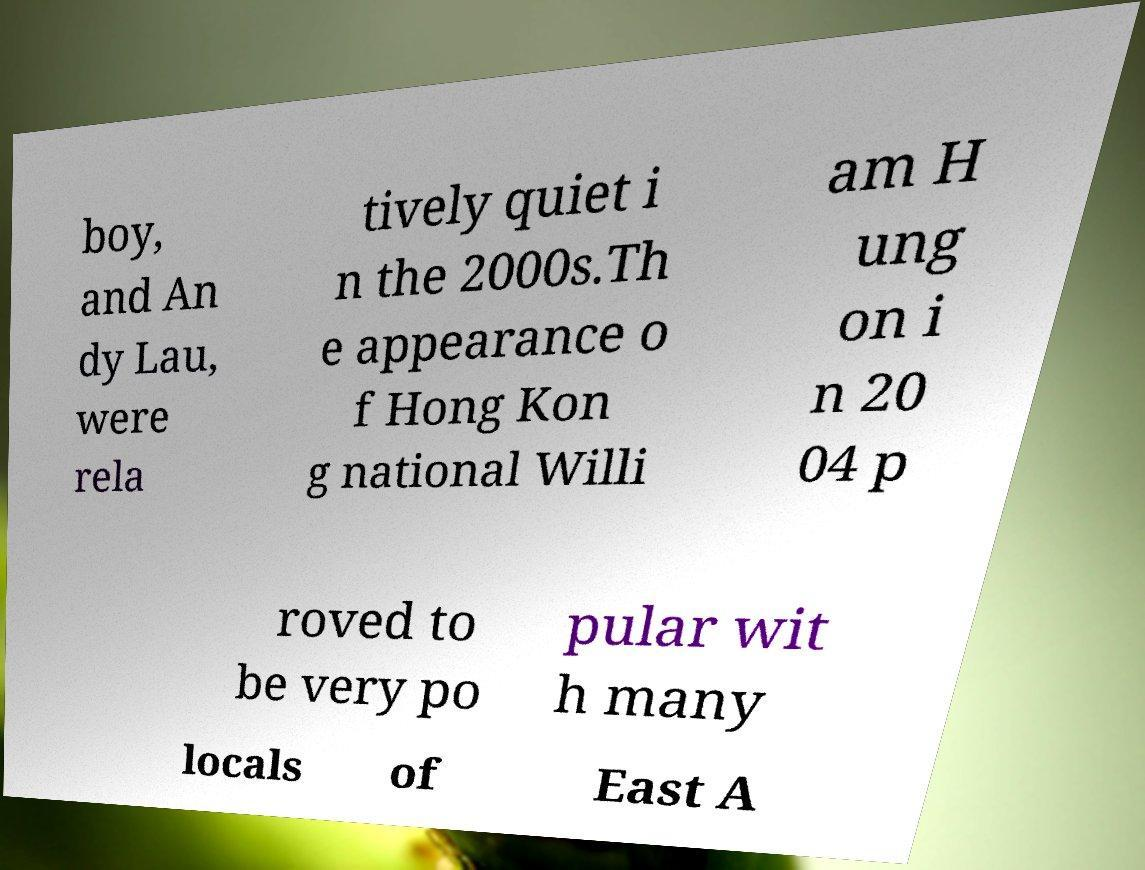What messages or text are displayed in this image? I need them in a readable, typed format. boy, and An dy Lau, were rela tively quiet i n the 2000s.Th e appearance o f Hong Kon g national Willi am H ung on i n 20 04 p roved to be very po pular wit h many locals of East A 